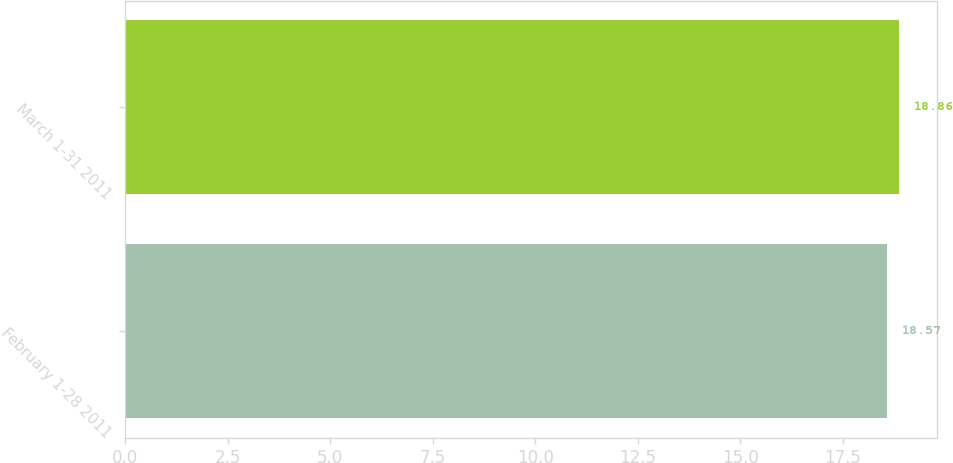Convert chart. <chart><loc_0><loc_0><loc_500><loc_500><bar_chart><fcel>February 1-28 2011<fcel>March 1-31 2011<nl><fcel>18.57<fcel>18.86<nl></chart> 